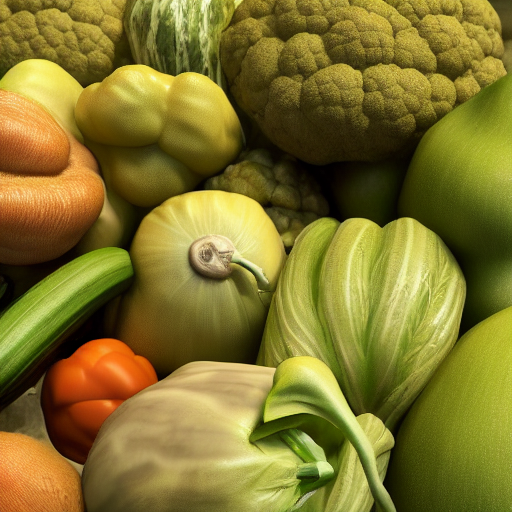How does the composition of this image inform us about the principles of healthy eating? The image, with its assortment of colorful vegetables, visually reinforces the principle of eating a variety of foods to obtain a range of nutrients. The diverse colors can be associated with different vitamins and minerals, promoting the idea that a colorful plate is a healthier plate. 